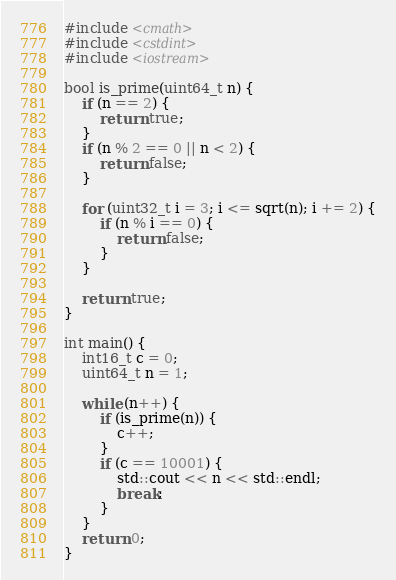Convert code to text. <code><loc_0><loc_0><loc_500><loc_500><_C++_>#include <cmath>
#include <cstdint>
#include <iostream>

bool is_prime(uint64_t n) {
    if (n == 2) {
        return true;
    }
    if (n % 2 == 0 || n < 2) {
        return false;
    }

    for (uint32_t i = 3; i <= sqrt(n); i += 2) {
        if (n % i == 0) {
            return false;
        }
    }

    return true;
}

int main() {
    int16_t c = 0;
    uint64_t n = 1;

    while (n++) {
        if (is_prime(n)) {
            c++;
        }
        if (c == 10001) {
            std::cout << n << std::endl;
            break;
        }
    }
    return 0;
}
</code> 